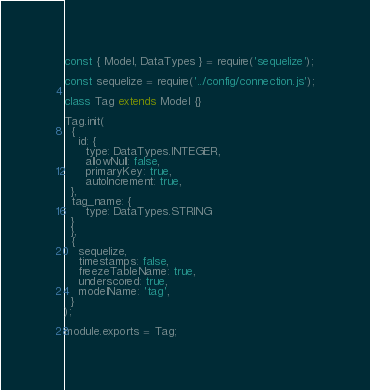<code> <loc_0><loc_0><loc_500><loc_500><_JavaScript_>const { Model, DataTypes } = require('sequelize');

const sequelize = require('../config/connection.js');

class Tag extends Model {}

Tag.init(
  {
    id: {
      type: DataTypes.INTEGER,
      allowNull: false,
      primaryKey: true,
      autoIncrement: true,
  },
  tag_name: {
      type: DataTypes.STRING
  }
  },
  {
    sequelize,
    timestamps: false,
    freezeTableName: true,
    underscored: true,
    modelName: 'tag',
  }
);

module.exports = Tag;
</code> 